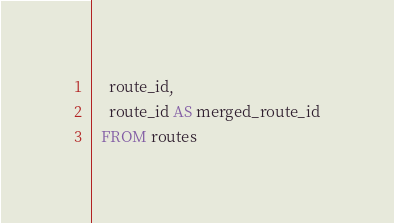Convert code to text. <code><loc_0><loc_0><loc_500><loc_500><_SQL_>    route_id,
    route_id AS merged_route_id
  FROM routes
</code> 